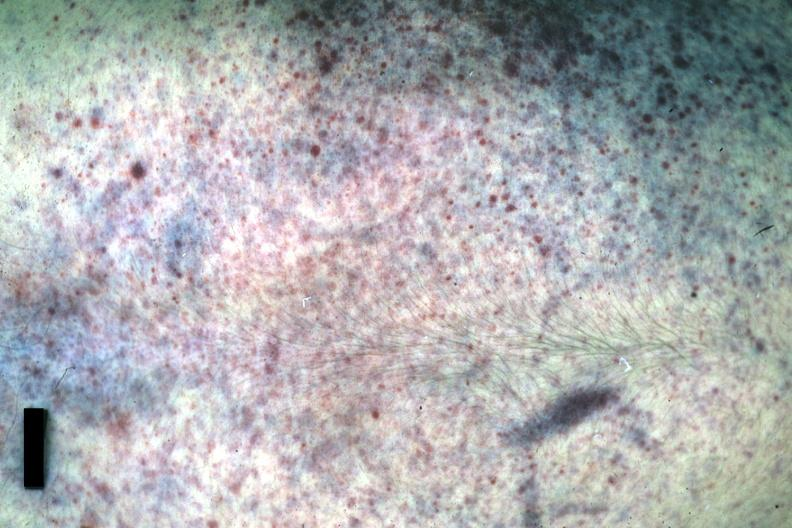what does this image show?
Answer the question using a single word or phrase. Good example either chest was anterior or posterior 